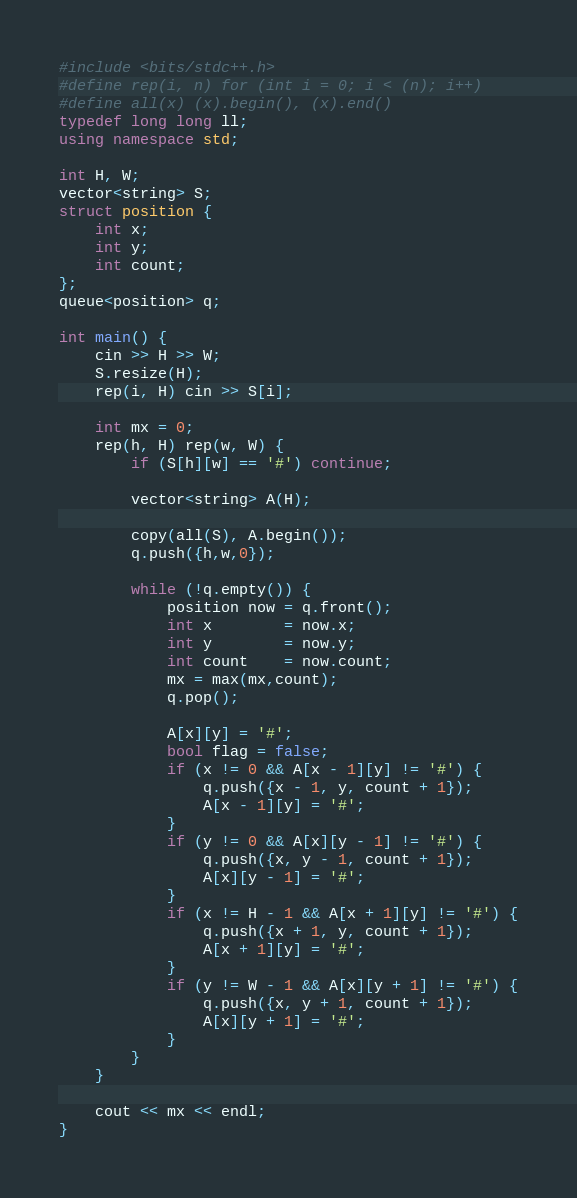<code> <loc_0><loc_0><loc_500><loc_500><_C++_>#include <bits/stdc++.h>
#define rep(i, n) for (int i = 0; i < (n); i++)
#define all(x) (x).begin(), (x).end()
typedef long long ll;
using namespace std;

int H, W;
vector<string> S;
struct position {
    int x;
    int y;
    int count;
};
queue<position> q;

int main() {
    cin >> H >> W;
    S.resize(H);
    rep(i, H) cin >> S[i];

    int mx = 0;
    rep(h, H) rep(w, W) {
        if (S[h][w] == '#') continue;

        vector<string> A(H);

        copy(all(S), A.begin());
        q.push({h,w,0});

        while (!q.empty()) {
            position now = q.front();
            int x        = now.x;
            int y        = now.y;
            int count    = now.count;
            mx = max(mx,count);
            q.pop();

            A[x][y] = '#';
            bool flag = false;
            if (x != 0 && A[x - 1][y] != '#') {
                q.push({x - 1, y, count + 1});
                A[x - 1][y] = '#';
            }
            if (y != 0 && A[x][y - 1] != '#') {
                q.push({x, y - 1, count + 1});
                A[x][y - 1] = '#';
            }
            if (x != H - 1 && A[x + 1][y] != '#') {
                q.push({x + 1, y, count + 1});
                A[x + 1][y] = '#';
            }
            if (y != W - 1 && A[x][y + 1] != '#') {
                q.push({x, y + 1, count + 1});
                A[x][y + 1] = '#';
            }
        }
    }

    cout << mx << endl;
}</code> 